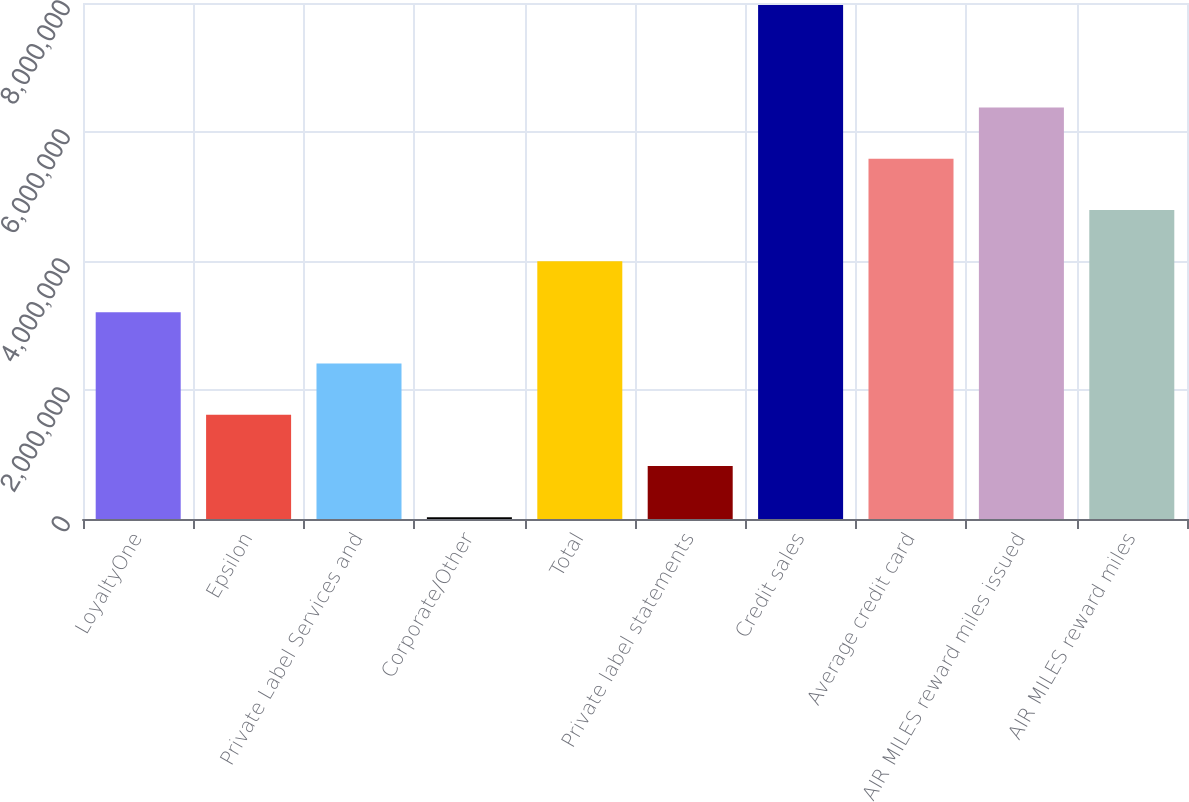<chart> <loc_0><loc_0><loc_500><loc_500><bar_chart><fcel>LoyaltyOne<fcel>Epsilon<fcel>Private Label Services and<fcel>Corporate/Other<fcel>Total<fcel>Private label statements<fcel>Credit sales<fcel>Average credit card<fcel>AIR MILES reward miles issued<fcel>AIR MILES reward miles<nl><fcel>3.20368e+06<fcel>1.61553e+06<fcel>2.40961e+06<fcel>27385<fcel>3.99776e+06<fcel>821459<fcel>7.96812e+06<fcel>5.5859e+06<fcel>6.37998e+06<fcel>4.79183e+06<nl></chart> 